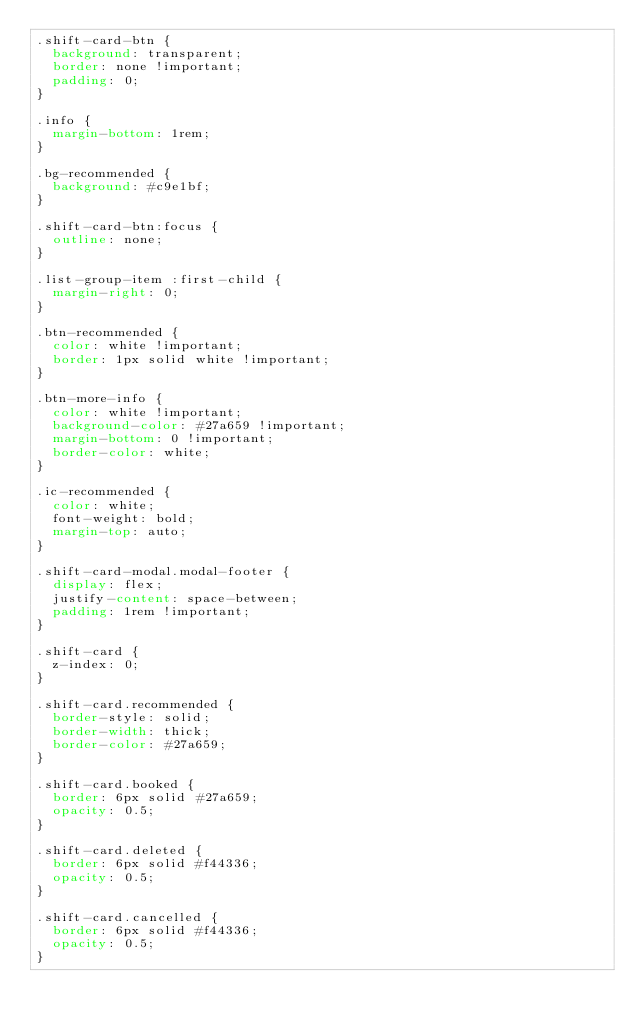<code> <loc_0><loc_0><loc_500><loc_500><_CSS_>.shift-card-btn {
  background: transparent;
  border: none !important;
  padding: 0;
}

.info {
  margin-bottom: 1rem;
}

.bg-recommended {
  background: #c9e1bf;
}

.shift-card-btn:focus {
  outline: none;
}

.list-group-item :first-child {
  margin-right: 0;
}

.btn-recommended {
  color: white !important;
  border: 1px solid white !important;
}

.btn-more-info {
  color: white !important;
  background-color: #27a659 !important;
  margin-bottom: 0 !important;
  border-color: white;
}

.ic-recommended {
  color: white;
  font-weight: bold;
  margin-top: auto;
}

.shift-card-modal.modal-footer {
  display: flex;
  justify-content: space-between;
  padding: 1rem !important;
}

.shift-card {
  z-index: 0;
}

.shift-card.recommended {
  border-style: solid;
  border-width: thick;
  border-color: #27a659;
}

.shift-card.booked {
  border: 6px solid #27a659;
  opacity: 0.5;
}

.shift-card.deleted {
  border: 6px solid #f44336;
  opacity: 0.5;
}

.shift-card.cancelled {
  border: 6px solid #f44336;
  opacity: 0.5;
}
</code> 